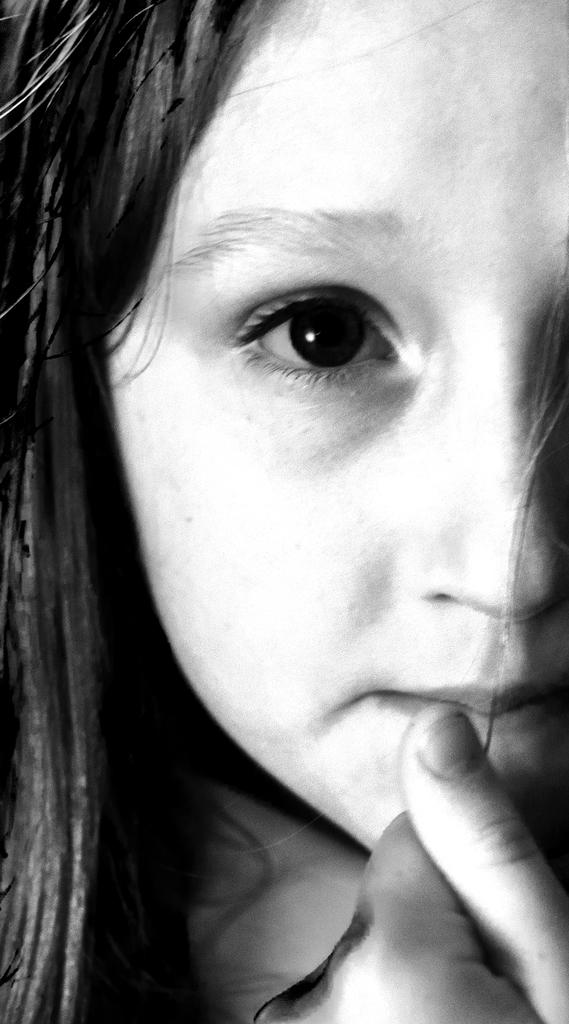What is the main subject of the image? There is a person in the image. Can you describe the person's hair color? The person has black hair. How many baseballs are visible in the image? There are no baseballs present in the image. 